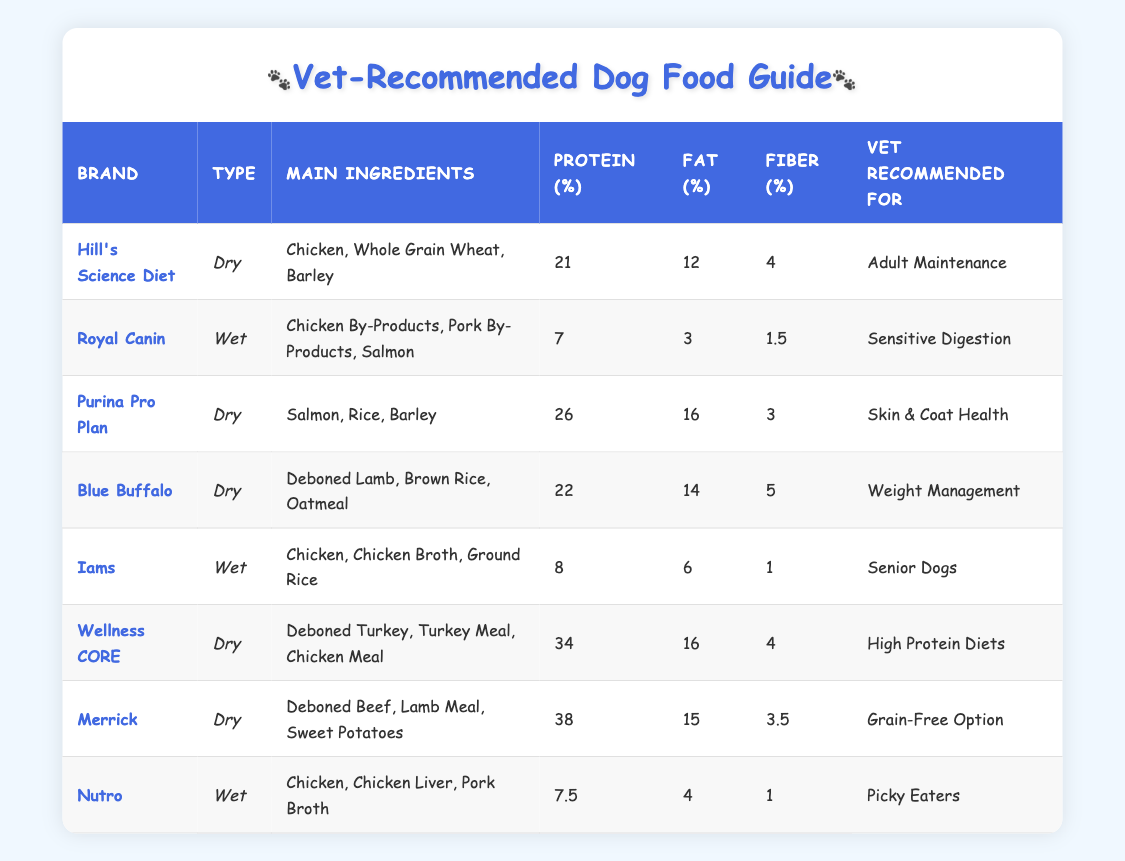What brand recommended for adult maintenance has the highest protein content? To find the answer, look for the row corresponding to "Adult Maintenance" under the "Vet Recommended For" column, which is Hill's Science Diet with 21% protein. Though there is another brand for adult maintenance, it has a lower protein value than Hill’s.
Answer: Hill's Science Diet Which dry dog food has the lowest fiber percentage? The fiber percentages of dry dog foods are 4, 5, and 3.5 for Hill's Science Diet, Blue Buffalo, and Merrick, respectively. The lowest is from Purina Pro Plan, which has 3% fiber.
Answer: Purina Pro Plan Is there a wet food option recommended for picky eaters? Yes, Nutro is marked as being recommended for picky eaters in the "Vet Recommended For" column under the Wet food type.
Answer: Yes What is the average protein percentage of all dry dog food brands listed? The protein percentages for all dry food brands are 21, 26, 22, 34, and 38. Adding them together gives 21 + 26 + 22 + 34 + 38 = 141. There are 5 brands, so the average protein percentage is 141 / 5 = 28.2.
Answer: 28.2 What are the main ingredients of the dog food recommended for sensitive digestion? From the table, the dog food brand "Royal Canin" is recommended for sensitive digestion and its main ingredients are Chicken By-Products, Pork By-Products, and Salmon.
Answer: Chicken By-Products, Pork By-Products, Salmon Which dog food type has the highest protein content? After comparing all protein values, Wellness CORE has the highest percentage at 34%, which qualifies it as a dry food type. The highest numbers can be traced through the protein column in the table.
Answer: Wellness CORE Do all the listed wet dog foods contain chicken as an ingredient? To determine this, check the main ingredients for each wet food. Royal Canin and Nutro both include chicken or chicken by-products, while Iams has chicken as the main ingredient.
Answer: Yes 